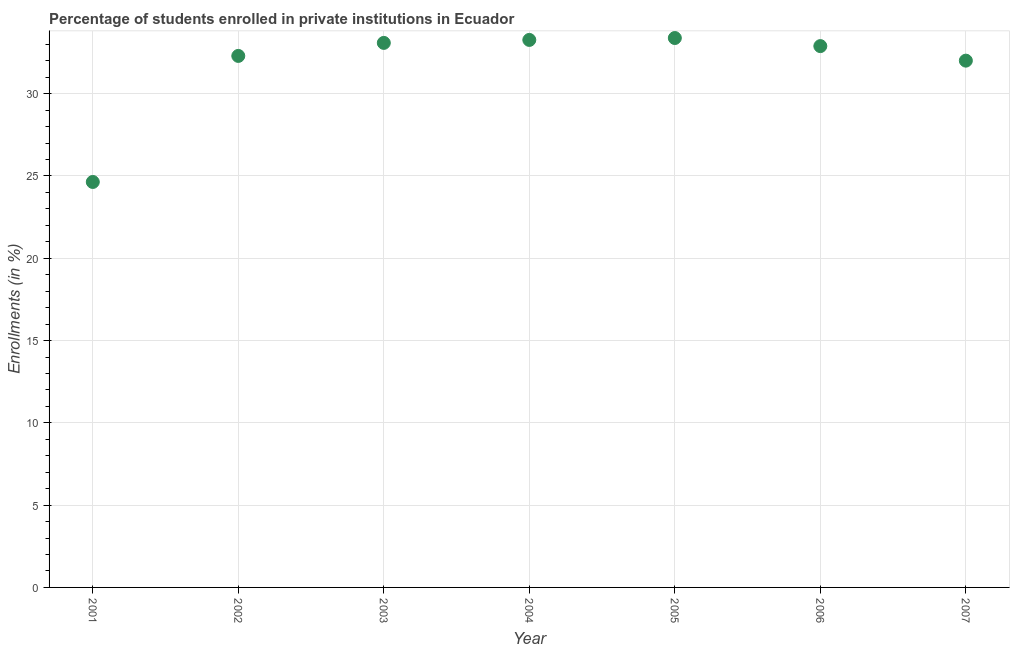What is the enrollments in private institutions in 2002?
Give a very brief answer. 32.3. Across all years, what is the maximum enrollments in private institutions?
Offer a very short reply. 33.38. Across all years, what is the minimum enrollments in private institutions?
Provide a succinct answer. 24.64. In which year was the enrollments in private institutions maximum?
Give a very brief answer. 2005. In which year was the enrollments in private institutions minimum?
Offer a terse response. 2001. What is the sum of the enrollments in private institutions?
Keep it short and to the point. 221.57. What is the difference between the enrollments in private institutions in 2002 and 2004?
Make the answer very short. -0.97. What is the average enrollments in private institutions per year?
Your answer should be compact. 31.65. What is the median enrollments in private institutions?
Your response must be concise. 32.89. In how many years, is the enrollments in private institutions greater than 24 %?
Provide a short and direct response. 7. Do a majority of the years between 2007 and 2006 (inclusive) have enrollments in private institutions greater than 7 %?
Your answer should be very brief. No. What is the ratio of the enrollments in private institutions in 2002 to that in 2007?
Offer a terse response. 1.01. Is the enrollments in private institutions in 2001 less than that in 2002?
Offer a terse response. Yes. What is the difference between the highest and the second highest enrollments in private institutions?
Ensure brevity in your answer.  0.12. Is the sum of the enrollments in private institutions in 2004 and 2005 greater than the maximum enrollments in private institutions across all years?
Provide a succinct answer. Yes. What is the difference between the highest and the lowest enrollments in private institutions?
Your answer should be compact. 8.75. Does the enrollments in private institutions monotonically increase over the years?
Your answer should be very brief. No. How many dotlines are there?
Provide a short and direct response. 1. How many years are there in the graph?
Your answer should be very brief. 7. Does the graph contain grids?
Your response must be concise. Yes. What is the title of the graph?
Provide a short and direct response. Percentage of students enrolled in private institutions in Ecuador. What is the label or title of the Y-axis?
Provide a succinct answer. Enrollments (in %). What is the Enrollments (in %) in 2001?
Your answer should be compact. 24.64. What is the Enrollments (in %) in 2002?
Your response must be concise. 32.3. What is the Enrollments (in %) in 2003?
Provide a succinct answer. 33.09. What is the Enrollments (in %) in 2004?
Offer a very short reply. 33.27. What is the Enrollments (in %) in 2005?
Give a very brief answer. 33.38. What is the Enrollments (in %) in 2006?
Your answer should be very brief. 32.89. What is the Enrollments (in %) in 2007?
Provide a succinct answer. 32.01. What is the difference between the Enrollments (in %) in 2001 and 2002?
Make the answer very short. -7.66. What is the difference between the Enrollments (in %) in 2001 and 2003?
Provide a short and direct response. -8.45. What is the difference between the Enrollments (in %) in 2001 and 2004?
Provide a short and direct response. -8.63. What is the difference between the Enrollments (in %) in 2001 and 2005?
Ensure brevity in your answer.  -8.75. What is the difference between the Enrollments (in %) in 2001 and 2006?
Your response must be concise. -8.26. What is the difference between the Enrollments (in %) in 2001 and 2007?
Provide a short and direct response. -7.37. What is the difference between the Enrollments (in %) in 2002 and 2003?
Give a very brief answer. -0.79. What is the difference between the Enrollments (in %) in 2002 and 2004?
Offer a terse response. -0.97. What is the difference between the Enrollments (in %) in 2002 and 2005?
Your answer should be compact. -1.09. What is the difference between the Enrollments (in %) in 2002 and 2006?
Your answer should be very brief. -0.6. What is the difference between the Enrollments (in %) in 2002 and 2007?
Provide a short and direct response. 0.29. What is the difference between the Enrollments (in %) in 2003 and 2004?
Offer a terse response. -0.18. What is the difference between the Enrollments (in %) in 2003 and 2005?
Provide a short and direct response. -0.3. What is the difference between the Enrollments (in %) in 2003 and 2006?
Your response must be concise. 0.2. What is the difference between the Enrollments (in %) in 2003 and 2007?
Provide a short and direct response. 1.08. What is the difference between the Enrollments (in %) in 2004 and 2005?
Provide a short and direct response. -0.12. What is the difference between the Enrollments (in %) in 2004 and 2006?
Keep it short and to the point. 0.38. What is the difference between the Enrollments (in %) in 2004 and 2007?
Keep it short and to the point. 1.26. What is the difference between the Enrollments (in %) in 2005 and 2006?
Your answer should be compact. 0.49. What is the difference between the Enrollments (in %) in 2005 and 2007?
Keep it short and to the point. 1.37. What is the difference between the Enrollments (in %) in 2006 and 2007?
Your response must be concise. 0.88. What is the ratio of the Enrollments (in %) in 2001 to that in 2002?
Ensure brevity in your answer.  0.76. What is the ratio of the Enrollments (in %) in 2001 to that in 2003?
Make the answer very short. 0.74. What is the ratio of the Enrollments (in %) in 2001 to that in 2004?
Keep it short and to the point. 0.74. What is the ratio of the Enrollments (in %) in 2001 to that in 2005?
Your response must be concise. 0.74. What is the ratio of the Enrollments (in %) in 2001 to that in 2006?
Make the answer very short. 0.75. What is the ratio of the Enrollments (in %) in 2001 to that in 2007?
Keep it short and to the point. 0.77. What is the ratio of the Enrollments (in %) in 2002 to that in 2004?
Offer a terse response. 0.97. What is the ratio of the Enrollments (in %) in 2003 to that in 2005?
Provide a succinct answer. 0.99. What is the ratio of the Enrollments (in %) in 2003 to that in 2007?
Ensure brevity in your answer.  1.03. What is the ratio of the Enrollments (in %) in 2004 to that in 2006?
Ensure brevity in your answer.  1.01. What is the ratio of the Enrollments (in %) in 2004 to that in 2007?
Provide a succinct answer. 1.04. What is the ratio of the Enrollments (in %) in 2005 to that in 2006?
Your answer should be compact. 1.01. What is the ratio of the Enrollments (in %) in 2005 to that in 2007?
Offer a very short reply. 1.04. What is the ratio of the Enrollments (in %) in 2006 to that in 2007?
Provide a succinct answer. 1.03. 